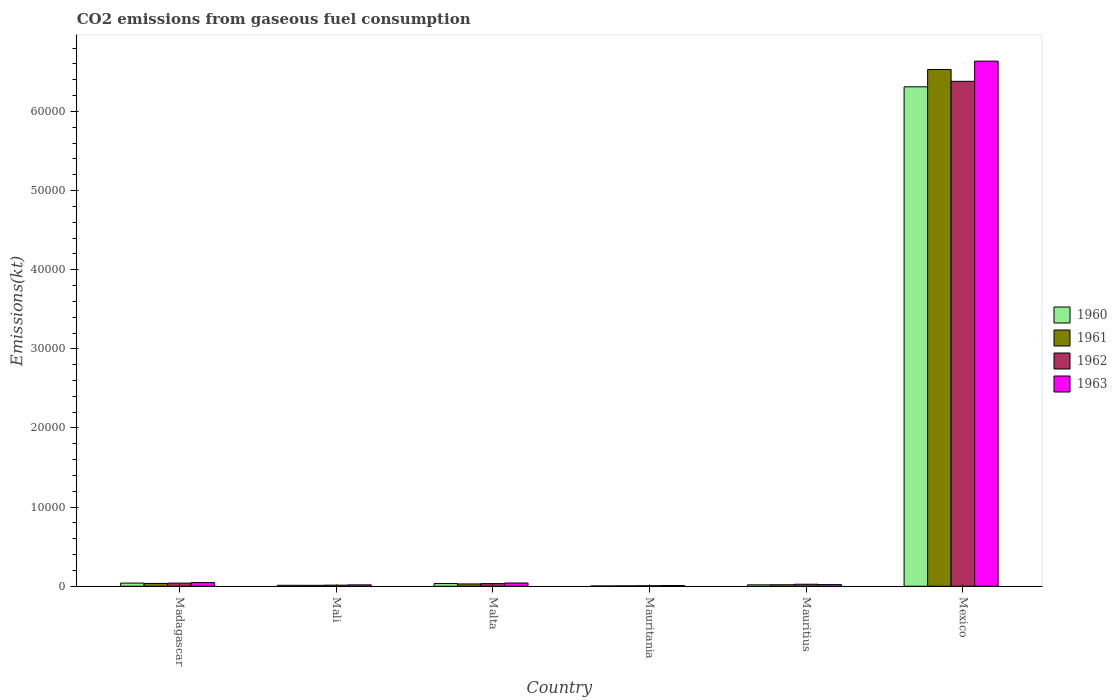Are the number of bars on each tick of the X-axis equal?
Offer a very short reply. Yes. What is the label of the 5th group of bars from the left?
Give a very brief answer. Mauritius. What is the amount of CO2 emitted in 1963 in Mauritius?
Your response must be concise. 209.02. Across all countries, what is the maximum amount of CO2 emitted in 1963?
Provide a succinct answer. 6.64e+04. Across all countries, what is the minimum amount of CO2 emitted in 1961?
Make the answer very short. 47.67. In which country was the amount of CO2 emitted in 1963 maximum?
Keep it short and to the point. Mexico. In which country was the amount of CO2 emitted in 1963 minimum?
Ensure brevity in your answer.  Mauritania. What is the total amount of CO2 emitted in 1961 in the graph?
Your answer should be compact. 6.63e+04. What is the difference between the amount of CO2 emitted in 1961 in Mauritius and that in Mexico?
Your response must be concise. -6.51e+04. What is the difference between the amount of CO2 emitted in 1961 in Malta and the amount of CO2 emitted in 1963 in Mali?
Make the answer very short. 117.34. What is the average amount of CO2 emitted in 1960 per country?
Offer a terse response. 1.07e+04. What is the difference between the amount of CO2 emitted of/in 1962 and amount of CO2 emitted of/in 1963 in Mali?
Your response must be concise. -36.67. In how many countries, is the amount of CO2 emitted in 1963 greater than 4000 kt?
Provide a short and direct response. 1. What is the ratio of the amount of CO2 emitted in 1963 in Mauritius to that in Mexico?
Give a very brief answer. 0. Is the amount of CO2 emitted in 1961 in Madagascar less than that in Mauritius?
Your answer should be very brief. No. What is the difference between the highest and the second highest amount of CO2 emitted in 1962?
Give a very brief answer. 6.35e+04. What is the difference between the highest and the lowest amount of CO2 emitted in 1963?
Your answer should be compact. 6.63e+04. In how many countries, is the amount of CO2 emitted in 1962 greater than the average amount of CO2 emitted in 1962 taken over all countries?
Provide a succinct answer. 1. Is it the case that in every country, the sum of the amount of CO2 emitted in 1963 and amount of CO2 emitted in 1960 is greater than the sum of amount of CO2 emitted in 1961 and amount of CO2 emitted in 1962?
Make the answer very short. No. What does the 1st bar from the left in Mali represents?
Make the answer very short. 1960. Is it the case that in every country, the sum of the amount of CO2 emitted in 1962 and amount of CO2 emitted in 1960 is greater than the amount of CO2 emitted in 1961?
Your answer should be compact. Yes. How many bars are there?
Provide a short and direct response. 24. Are all the bars in the graph horizontal?
Keep it short and to the point. No. How many countries are there in the graph?
Make the answer very short. 6. What is the difference between two consecutive major ticks on the Y-axis?
Your answer should be compact. 10000. Are the values on the major ticks of Y-axis written in scientific E-notation?
Keep it short and to the point. No. How many legend labels are there?
Make the answer very short. 4. What is the title of the graph?
Make the answer very short. CO2 emissions from gaseous fuel consumption. Does "1982" appear as one of the legend labels in the graph?
Your response must be concise. No. What is the label or title of the X-axis?
Make the answer very short. Country. What is the label or title of the Y-axis?
Keep it short and to the point. Emissions(kt). What is the Emissions(kt) in 1960 in Madagascar?
Offer a terse response. 399.7. What is the Emissions(kt) in 1961 in Madagascar?
Offer a terse response. 355.7. What is the Emissions(kt) of 1962 in Madagascar?
Keep it short and to the point. 396.04. What is the Emissions(kt) of 1963 in Madagascar?
Offer a very short reply. 462.04. What is the Emissions(kt) in 1960 in Mali?
Your response must be concise. 121.01. What is the Emissions(kt) of 1961 in Mali?
Your answer should be compact. 117.34. What is the Emissions(kt) of 1962 in Mali?
Keep it short and to the point. 139.35. What is the Emissions(kt) of 1963 in Mali?
Offer a terse response. 176.02. What is the Emissions(kt) in 1960 in Malta?
Offer a terse response. 341.03. What is the Emissions(kt) of 1961 in Malta?
Provide a short and direct response. 293.36. What is the Emissions(kt) in 1962 in Malta?
Provide a succinct answer. 330.03. What is the Emissions(kt) of 1963 in Malta?
Your answer should be very brief. 410.7. What is the Emissions(kt) in 1960 in Mauritania?
Your response must be concise. 36.67. What is the Emissions(kt) of 1961 in Mauritania?
Provide a succinct answer. 47.67. What is the Emissions(kt) of 1962 in Mauritania?
Ensure brevity in your answer.  62.34. What is the Emissions(kt) in 1963 in Mauritania?
Your answer should be compact. 88.01. What is the Emissions(kt) of 1960 in Mauritius?
Give a very brief answer. 179.68. What is the Emissions(kt) of 1961 in Mauritius?
Ensure brevity in your answer.  187.02. What is the Emissions(kt) of 1962 in Mauritius?
Offer a very short reply. 253.02. What is the Emissions(kt) of 1963 in Mauritius?
Keep it short and to the point. 209.02. What is the Emissions(kt) of 1960 in Mexico?
Your answer should be compact. 6.31e+04. What is the Emissions(kt) in 1961 in Mexico?
Give a very brief answer. 6.53e+04. What is the Emissions(kt) in 1962 in Mexico?
Your response must be concise. 6.38e+04. What is the Emissions(kt) of 1963 in Mexico?
Give a very brief answer. 6.64e+04. Across all countries, what is the maximum Emissions(kt) of 1960?
Offer a terse response. 6.31e+04. Across all countries, what is the maximum Emissions(kt) in 1961?
Give a very brief answer. 6.53e+04. Across all countries, what is the maximum Emissions(kt) of 1962?
Your response must be concise. 6.38e+04. Across all countries, what is the maximum Emissions(kt) in 1963?
Offer a terse response. 6.64e+04. Across all countries, what is the minimum Emissions(kt) of 1960?
Your answer should be compact. 36.67. Across all countries, what is the minimum Emissions(kt) of 1961?
Offer a terse response. 47.67. Across all countries, what is the minimum Emissions(kt) of 1962?
Offer a terse response. 62.34. Across all countries, what is the minimum Emissions(kt) in 1963?
Keep it short and to the point. 88.01. What is the total Emissions(kt) of 1960 in the graph?
Offer a very short reply. 6.42e+04. What is the total Emissions(kt) of 1961 in the graph?
Offer a very short reply. 6.63e+04. What is the total Emissions(kt) of 1962 in the graph?
Make the answer very short. 6.50e+04. What is the total Emissions(kt) in 1963 in the graph?
Your response must be concise. 6.77e+04. What is the difference between the Emissions(kt) of 1960 in Madagascar and that in Mali?
Your answer should be very brief. 278.69. What is the difference between the Emissions(kt) of 1961 in Madagascar and that in Mali?
Provide a short and direct response. 238.35. What is the difference between the Emissions(kt) in 1962 in Madagascar and that in Mali?
Offer a very short reply. 256.69. What is the difference between the Emissions(kt) of 1963 in Madagascar and that in Mali?
Make the answer very short. 286.03. What is the difference between the Emissions(kt) in 1960 in Madagascar and that in Malta?
Your response must be concise. 58.67. What is the difference between the Emissions(kt) of 1961 in Madagascar and that in Malta?
Provide a short and direct response. 62.34. What is the difference between the Emissions(kt) in 1962 in Madagascar and that in Malta?
Offer a terse response. 66.01. What is the difference between the Emissions(kt) of 1963 in Madagascar and that in Malta?
Provide a short and direct response. 51.34. What is the difference between the Emissions(kt) of 1960 in Madagascar and that in Mauritania?
Offer a terse response. 363.03. What is the difference between the Emissions(kt) in 1961 in Madagascar and that in Mauritania?
Provide a short and direct response. 308.03. What is the difference between the Emissions(kt) of 1962 in Madagascar and that in Mauritania?
Ensure brevity in your answer.  333.7. What is the difference between the Emissions(kt) in 1963 in Madagascar and that in Mauritania?
Ensure brevity in your answer.  374.03. What is the difference between the Emissions(kt) of 1960 in Madagascar and that in Mauritius?
Provide a short and direct response. 220.02. What is the difference between the Emissions(kt) in 1961 in Madagascar and that in Mauritius?
Your response must be concise. 168.68. What is the difference between the Emissions(kt) of 1962 in Madagascar and that in Mauritius?
Offer a very short reply. 143.01. What is the difference between the Emissions(kt) of 1963 in Madagascar and that in Mauritius?
Give a very brief answer. 253.02. What is the difference between the Emissions(kt) of 1960 in Madagascar and that in Mexico?
Your answer should be compact. -6.27e+04. What is the difference between the Emissions(kt) of 1961 in Madagascar and that in Mexico?
Offer a very short reply. -6.49e+04. What is the difference between the Emissions(kt) of 1962 in Madagascar and that in Mexico?
Offer a terse response. -6.34e+04. What is the difference between the Emissions(kt) of 1963 in Madagascar and that in Mexico?
Give a very brief answer. -6.59e+04. What is the difference between the Emissions(kt) in 1960 in Mali and that in Malta?
Provide a succinct answer. -220.02. What is the difference between the Emissions(kt) in 1961 in Mali and that in Malta?
Offer a terse response. -176.02. What is the difference between the Emissions(kt) in 1962 in Mali and that in Malta?
Your response must be concise. -190.68. What is the difference between the Emissions(kt) in 1963 in Mali and that in Malta?
Provide a short and direct response. -234.69. What is the difference between the Emissions(kt) in 1960 in Mali and that in Mauritania?
Provide a short and direct response. 84.34. What is the difference between the Emissions(kt) of 1961 in Mali and that in Mauritania?
Ensure brevity in your answer.  69.67. What is the difference between the Emissions(kt) of 1962 in Mali and that in Mauritania?
Your answer should be compact. 77.01. What is the difference between the Emissions(kt) in 1963 in Mali and that in Mauritania?
Provide a succinct answer. 88.01. What is the difference between the Emissions(kt) in 1960 in Mali and that in Mauritius?
Provide a succinct answer. -58.67. What is the difference between the Emissions(kt) in 1961 in Mali and that in Mauritius?
Make the answer very short. -69.67. What is the difference between the Emissions(kt) of 1962 in Mali and that in Mauritius?
Give a very brief answer. -113.68. What is the difference between the Emissions(kt) of 1963 in Mali and that in Mauritius?
Your response must be concise. -33. What is the difference between the Emissions(kt) in 1960 in Mali and that in Mexico?
Offer a very short reply. -6.30e+04. What is the difference between the Emissions(kt) in 1961 in Mali and that in Mexico?
Ensure brevity in your answer.  -6.52e+04. What is the difference between the Emissions(kt) of 1962 in Mali and that in Mexico?
Your response must be concise. -6.37e+04. What is the difference between the Emissions(kt) of 1963 in Mali and that in Mexico?
Your answer should be very brief. -6.62e+04. What is the difference between the Emissions(kt) in 1960 in Malta and that in Mauritania?
Your response must be concise. 304.36. What is the difference between the Emissions(kt) of 1961 in Malta and that in Mauritania?
Ensure brevity in your answer.  245.69. What is the difference between the Emissions(kt) in 1962 in Malta and that in Mauritania?
Offer a very short reply. 267.69. What is the difference between the Emissions(kt) in 1963 in Malta and that in Mauritania?
Make the answer very short. 322.7. What is the difference between the Emissions(kt) in 1960 in Malta and that in Mauritius?
Make the answer very short. 161.35. What is the difference between the Emissions(kt) in 1961 in Malta and that in Mauritius?
Ensure brevity in your answer.  106.34. What is the difference between the Emissions(kt) in 1962 in Malta and that in Mauritius?
Give a very brief answer. 77.01. What is the difference between the Emissions(kt) in 1963 in Malta and that in Mauritius?
Ensure brevity in your answer.  201.69. What is the difference between the Emissions(kt) of 1960 in Malta and that in Mexico?
Offer a very short reply. -6.28e+04. What is the difference between the Emissions(kt) of 1961 in Malta and that in Mexico?
Keep it short and to the point. -6.50e+04. What is the difference between the Emissions(kt) of 1962 in Malta and that in Mexico?
Your answer should be compact. -6.35e+04. What is the difference between the Emissions(kt) in 1963 in Malta and that in Mexico?
Your answer should be very brief. -6.60e+04. What is the difference between the Emissions(kt) in 1960 in Mauritania and that in Mauritius?
Your response must be concise. -143.01. What is the difference between the Emissions(kt) in 1961 in Mauritania and that in Mauritius?
Make the answer very short. -139.35. What is the difference between the Emissions(kt) of 1962 in Mauritania and that in Mauritius?
Keep it short and to the point. -190.68. What is the difference between the Emissions(kt) of 1963 in Mauritania and that in Mauritius?
Your answer should be very brief. -121.01. What is the difference between the Emissions(kt) in 1960 in Mauritania and that in Mexico?
Your answer should be compact. -6.31e+04. What is the difference between the Emissions(kt) of 1961 in Mauritania and that in Mexico?
Ensure brevity in your answer.  -6.53e+04. What is the difference between the Emissions(kt) in 1962 in Mauritania and that in Mexico?
Your answer should be very brief. -6.37e+04. What is the difference between the Emissions(kt) in 1963 in Mauritania and that in Mexico?
Keep it short and to the point. -6.63e+04. What is the difference between the Emissions(kt) of 1960 in Mauritius and that in Mexico?
Keep it short and to the point. -6.29e+04. What is the difference between the Emissions(kt) in 1961 in Mauritius and that in Mexico?
Your answer should be compact. -6.51e+04. What is the difference between the Emissions(kt) in 1962 in Mauritius and that in Mexico?
Your answer should be very brief. -6.36e+04. What is the difference between the Emissions(kt) in 1963 in Mauritius and that in Mexico?
Your answer should be very brief. -6.62e+04. What is the difference between the Emissions(kt) in 1960 in Madagascar and the Emissions(kt) in 1961 in Mali?
Your response must be concise. 282.36. What is the difference between the Emissions(kt) in 1960 in Madagascar and the Emissions(kt) in 1962 in Mali?
Your answer should be compact. 260.36. What is the difference between the Emissions(kt) in 1960 in Madagascar and the Emissions(kt) in 1963 in Mali?
Your answer should be very brief. 223.69. What is the difference between the Emissions(kt) of 1961 in Madagascar and the Emissions(kt) of 1962 in Mali?
Provide a succinct answer. 216.35. What is the difference between the Emissions(kt) of 1961 in Madagascar and the Emissions(kt) of 1963 in Mali?
Give a very brief answer. 179.68. What is the difference between the Emissions(kt) of 1962 in Madagascar and the Emissions(kt) of 1963 in Mali?
Offer a terse response. 220.02. What is the difference between the Emissions(kt) of 1960 in Madagascar and the Emissions(kt) of 1961 in Malta?
Make the answer very short. 106.34. What is the difference between the Emissions(kt) in 1960 in Madagascar and the Emissions(kt) in 1962 in Malta?
Offer a very short reply. 69.67. What is the difference between the Emissions(kt) in 1960 in Madagascar and the Emissions(kt) in 1963 in Malta?
Keep it short and to the point. -11. What is the difference between the Emissions(kt) in 1961 in Madagascar and the Emissions(kt) in 1962 in Malta?
Offer a terse response. 25.67. What is the difference between the Emissions(kt) of 1961 in Madagascar and the Emissions(kt) of 1963 in Malta?
Your answer should be very brief. -55.01. What is the difference between the Emissions(kt) in 1962 in Madagascar and the Emissions(kt) in 1963 in Malta?
Ensure brevity in your answer.  -14.67. What is the difference between the Emissions(kt) of 1960 in Madagascar and the Emissions(kt) of 1961 in Mauritania?
Your answer should be very brief. 352.03. What is the difference between the Emissions(kt) in 1960 in Madagascar and the Emissions(kt) in 1962 in Mauritania?
Offer a terse response. 337.36. What is the difference between the Emissions(kt) of 1960 in Madagascar and the Emissions(kt) of 1963 in Mauritania?
Offer a terse response. 311.69. What is the difference between the Emissions(kt) of 1961 in Madagascar and the Emissions(kt) of 1962 in Mauritania?
Your response must be concise. 293.36. What is the difference between the Emissions(kt) in 1961 in Madagascar and the Emissions(kt) in 1963 in Mauritania?
Provide a succinct answer. 267.69. What is the difference between the Emissions(kt) of 1962 in Madagascar and the Emissions(kt) of 1963 in Mauritania?
Provide a succinct answer. 308.03. What is the difference between the Emissions(kt) of 1960 in Madagascar and the Emissions(kt) of 1961 in Mauritius?
Make the answer very short. 212.69. What is the difference between the Emissions(kt) of 1960 in Madagascar and the Emissions(kt) of 1962 in Mauritius?
Keep it short and to the point. 146.68. What is the difference between the Emissions(kt) of 1960 in Madagascar and the Emissions(kt) of 1963 in Mauritius?
Your response must be concise. 190.68. What is the difference between the Emissions(kt) of 1961 in Madagascar and the Emissions(kt) of 1962 in Mauritius?
Offer a very short reply. 102.68. What is the difference between the Emissions(kt) in 1961 in Madagascar and the Emissions(kt) in 1963 in Mauritius?
Your response must be concise. 146.68. What is the difference between the Emissions(kt) of 1962 in Madagascar and the Emissions(kt) of 1963 in Mauritius?
Provide a succinct answer. 187.02. What is the difference between the Emissions(kt) in 1960 in Madagascar and the Emissions(kt) in 1961 in Mexico?
Offer a terse response. -6.49e+04. What is the difference between the Emissions(kt) of 1960 in Madagascar and the Emissions(kt) of 1962 in Mexico?
Keep it short and to the point. -6.34e+04. What is the difference between the Emissions(kt) of 1960 in Madagascar and the Emissions(kt) of 1963 in Mexico?
Keep it short and to the point. -6.60e+04. What is the difference between the Emissions(kt) of 1961 in Madagascar and the Emissions(kt) of 1962 in Mexico?
Provide a succinct answer. -6.35e+04. What is the difference between the Emissions(kt) in 1961 in Madagascar and the Emissions(kt) in 1963 in Mexico?
Your answer should be compact. -6.60e+04. What is the difference between the Emissions(kt) of 1962 in Madagascar and the Emissions(kt) of 1963 in Mexico?
Your answer should be very brief. -6.60e+04. What is the difference between the Emissions(kt) of 1960 in Mali and the Emissions(kt) of 1961 in Malta?
Provide a succinct answer. -172.35. What is the difference between the Emissions(kt) in 1960 in Mali and the Emissions(kt) in 1962 in Malta?
Provide a succinct answer. -209.02. What is the difference between the Emissions(kt) of 1960 in Mali and the Emissions(kt) of 1963 in Malta?
Offer a terse response. -289.69. What is the difference between the Emissions(kt) of 1961 in Mali and the Emissions(kt) of 1962 in Malta?
Your answer should be compact. -212.69. What is the difference between the Emissions(kt) in 1961 in Mali and the Emissions(kt) in 1963 in Malta?
Keep it short and to the point. -293.36. What is the difference between the Emissions(kt) of 1962 in Mali and the Emissions(kt) of 1963 in Malta?
Provide a short and direct response. -271.36. What is the difference between the Emissions(kt) in 1960 in Mali and the Emissions(kt) in 1961 in Mauritania?
Ensure brevity in your answer.  73.34. What is the difference between the Emissions(kt) of 1960 in Mali and the Emissions(kt) of 1962 in Mauritania?
Offer a very short reply. 58.67. What is the difference between the Emissions(kt) of 1960 in Mali and the Emissions(kt) of 1963 in Mauritania?
Offer a very short reply. 33. What is the difference between the Emissions(kt) of 1961 in Mali and the Emissions(kt) of 1962 in Mauritania?
Your response must be concise. 55.01. What is the difference between the Emissions(kt) in 1961 in Mali and the Emissions(kt) in 1963 in Mauritania?
Provide a succinct answer. 29.34. What is the difference between the Emissions(kt) of 1962 in Mali and the Emissions(kt) of 1963 in Mauritania?
Make the answer very short. 51.34. What is the difference between the Emissions(kt) of 1960 in Mali and the Emissions(kt) of 1961 in Mauritius?
Provide a succinct answer. -66.01. What is the difference between the Emissions(kt) of 1960 in Mali and the Emissions(kt) of 1962 in Mauritius?
Ensure brevity in your answer.  -132.01. What is the difference between the Emissions(kt) of 1960 in Mali and the Emissions(kt) of 1963 in Mauritius?
Provide a succinct answer. -88.01. What is the difference between the Emissions(kt) of 1961 in Mali and the Emissions(kt) of 1962 in Mauritius?
Make the answer very short. -135.68. What is the difference between the Emissions(kt) in 1961 in Mali and the Emissions(kt) in 1963 in Mauritius?
Ensure brevity in your answer.  -91.67. What is the difference between the Emissions(kt) in 1962 in Mali and the Emissions(kt) in 1963 in Mauritius?
Keep it short and to the point. -69.67. What is the difference between the Emissions(kt) of 1960 in Mali and the Emissions(kt) of 1961 in Mexico?
Your response must be concise. -6.52e+04. What is the difference between the Emissions(kt) in 1960 in Mali and the Emissions(kt) in 1962 in Mexico?
Provide a short and direct response. -6.37e+04. What is the difference between the Emissions(kt) in 1960 in Mali and the Emissions(kt) in 1963 in Mexico?
Offer a terse response. -6.62e+04. What is the difference between the Emissions(kt) of 1961 in Mali and the Emissions(kt) of 1962 in Mexico?
Provide a short and direct response. -6.37e+04. What is the difference between the Emissions(kt) in 1961 in Mali and the Emissions(kt) in 1963 in Mexico?
Ensure brevity in your answer.  -6.62e+04. What is the difference between the Emissions(kt) of 1962 in Mali and the Emissions(kt) of 1963 in Mexico?
Provide a short and direct response. -6.62e+04. What is the difference between the Emissions(kt) of 1960 in Malta and the Emissions(kt) of 1961 in Mauritania?
Offer a terse response. 293.36. What is the difference between the Emissions(kt) of 1960 in Malta and the Emissions(kt) of 1962 in Mauritania?
Make the answer very short. 278.69. What is the difference between the Emissions(kt) in 1960 in Malta and the Emissions(kt) in 1963 in Mauritania?
Your response must be concise. 253.02. What is the difference between the Emissions(kt) of 1961 in Malta and the Emissions(kt) of 1962 in Mauritania?
Ensure brevity in your answer.  231.02. What is the difference between the Emissions(kt) of 1961 in Malta and the Emissions(kt) of 1963 in Mauritania?
Give a very brief answer. 205.35. What is the difference between the Emissions(kt) of 1962 in Malta and the Emissions(kt) of 1963 in Mauritania?
Give a very brief answer. 242.02. What is the difference between the Emissions(kt) of 1960 in Malta and the Emissions(kt) of 1961 in Mauritius?
Make the answer very short. 154.01. What is the difference between the Emissions(kt) in 1960 in Malta and the Emissions(kt) in 1962 in Mauritius?
Your answer should be compact. 88.01. What is the difference between the Emissions(kt) in 1960 in Malta and the Emissions(kt) in 1963 in Mauritius?
Keep it short and to the point. 132.01. What is the difference between the Emissions(kt) of 1961 in Malta and the Emissions(kt) of 1962 in Mauritius?
Your answer should be very brief. 40.34. What is the difference between the Emissions(kt) of 1961 in Malta and the Emissions(kt) of 1963 in Mauritius?
Your response must be concise. 84.34. What is the difference between the Emissions(kt) in 1962 in Malta and the Emissions(kt) in 1963 in Mauritius?
Your response must be concise. 121.01. What is the difference between the Emissions(kt) of 1960 in Malta and the Emissions(kt) of 1961 in Mexico?
Provide a short and direct response. -6.50e+04. What is the difference between the Emissions(kt) in 1960 in Malta and the Emissions(kt) in 1962 in Mexico?
Offer a terse response. -6.35e+04. What is the difference between the Emissions(kt) of 1960 in Malta and the Emissions(kt) of 1963 in Mexico?
Ensure brevity in your answer.  -6.60e+04. What is the difference between the Emissions(kt) in 1961 in Malta and the Emissions(kt) in 1962 in Mexico?
Provide a succinct answer. -6.35e+04. What is the difference between the Emissions(kt) of 1961 in Malta and the Emissions(kt) of 1963 in Mexico?
Your answer should be very brief. -6.61e+04. What is the difference between the Emissions(kt) of 1962 in Malta and the Emissions(kt) of 1963 in Mexico?
Offer a terse response. -6.60e+04. What is the difference between the Emissions(kt) in 1960 in Mauritania and the Emissions(kt) in 1961 in Mauritius?
Offer a terse response. -150.35. What is the difference between the Emissions(kt) in 1960 in Mauritania and the Emissions(kt) in 1962 in Mauritius?
Provide a short and direct response. -216.35. What is the difference between the Emissions(kt) of 1960 in Mauritania and the Emissions(kt) of 1963 in Mauritius?
Ensure brevity in your answer.  -172.35. What is the difference between the Emissions(kt) of 1961 in Mauritania and the Emissions(kt) of 1962 in Mauritius?
Your answer should be compact. -205.35. What is the difference between the Emissions(kt) in 1961 in Mauritania and the Emissions(kt) in 1963 in Mauritius?
Keep it short and to the point. -161.35. What is the difference between the Emissions(kt) in 1962 in Mauritania and the Emissions(kt) in 1963 in Mauritius?
Offer a very short reply. -146.68. What is the difference between the Emissions(kt) in 1960 in Mauritania and the Emissions(kt) in 1961 in Mexico?
Your answer should be very brief. -6.53e+04. What is the difference between the Emissions(kt) of 1960 in Mauritania and the Emissions(kt) of 1962 in Mexico?
Provide a succinct answer. -6.38e+04. What is the difference between the Emissions(kt) in 1960 in Mauritania and the Emissions(kt) in 1963 in Mexico?
Keep it short and to the point. -6.63e+04. What is the difference between the Emissions(kt) of 1961 in Mauritania and the Emissions(kt) of 1962 in Mexico?
Provide a short and direct response. -6.38e+04. What is the difference between the Emissions(kt) of 1961 in Mauritania and the Emissions(kt) of 1963 in Mexico?
Give a very brief answer. -6.63e+04. What is the difference between the Emissions(kt) of 1962 in Mauritania and the Emissions(kt) of 1963 in Mexico?
Give a very brief answer. -6.63e+04. What is the difference between the Emissions(kt) in 1960 in Mauritius and the Emissions(kt) in 1961 in Mexico?
Provide a succinct answer. -6.51e+04. What is the difference between the Emissions(kt) of 1960 in Mauritius and the Emissions(kt) of 1962 in Mexico?
Offer a very short reply. -6.36e+04. What is the difference between the Emissions(kt) in 1960 in Mauritius and the Emissions(kt) in 1963 in Mexico?
Offer a terse response. -6.62e+04. What is the difference between the Emissions(kt) of 1961 in Mauritius and the Emissions(kt) of 1962 in Mexico?
Give a very brief answer. -6.36e+04. What is the difference between the Emissions(kt) of 1961 in Mauritius and the Emissions(kt) of 1963 in Mexico?
Make the answer very short. -6.62e+04. What is the difference between the Emissions(kt) in 1962 in Mauritius and the Emissions(kt) in 1963 in Mexico?
Ensure brevity in your answer.  -6.61e+04. What is the average Emissions(kt) in 1960 per country?
Offer a very short reply. 1.07e+04. What is the average Emissions(kt) in 1961 per country?
Your answer should be compact. 1.11e+04. What is the average Emissions(kt) of 1962 per country?
Ensure brevity in your answer.  1.08e+04. What is the average Emissions(kt) of 1963 per country?
Provide a succinct answer. 1.13e+04. What is the difference between the Emissions(kt) of 1960 and Emissions(kt) of 1961 in Madagascar?
Make the answer very short. 44. What is the difference between the Emissions(kt) in 1960 and Emissions(kt) in 1962 in Madagascar?
Your answer should be very brief. 3.67. What is the difference between the Emissions(kt) in 1960 and Emissions(kt) in 1963 in Madagascar?
Ensure brevity in your answer.  -62.34. What is the difference between the Emissions(kt) in 1961 and Emissions(kt) in 1962 in Madagascar?
Ensure brevity in your answer.  -40.34. What is the difference between the Emissions(kt) of 1961 and Emissions(kt) of 1963 in Madagascar?
Give a very brief answer. -106.34. What is the difference between the Emissions(kt) in 1962 and Emissions(kt) in 1963 in Madagascar?
Your response must be concise. -66.01. What is the difference between the Emissions(kt) in 1960 and Emissions(kt) in 1961 in Mali?
Ensure brevity in your answer.  3.67. What is the difference between the Emissions(kt) of 1960 and Emissions(kt) of 1962 in Mali?
Keep it short and to the point. -18.34. What is the difference between the Emissions(kt) of 1960 and Emissions(kt) of 1963 in Mali?
Keep it short and to the point. -55.01. What is the difference between the Emissions(kt) of 1961 and Emissions(kt) of 1962 in Mali?
Give a very brief answer. -22. What is the difference between the Emissions(kt) of 1961 and Emissions(kt) of 1963 in Mali?
Ensure brevity in your answer.  -58.67. What is the difference between the Emissions(kt) of 1962 and Emissions(kt) of 1963 in Mali?
Ensure brevity in your answer.  -36.67. What is the difference between the Emissions(kt) in 1960 and Emissions(kt) in 1961 in Malta?
Your answer should be compact. 47.67. What is the difference between the Emissions(kt) of 1960 and Emissions(kt) of 1962 in Malta?
Ensure brevity in your answer.  11. What is the difference between the Emissions(kt) in 1960 and Emissions(kt) in 1963 in Malta?
Your response must be concise. -69.67. What is the difference between the Emissions(kt) in 1961 and Emissions(kt) in 1962 in Malta?
Provide a succinct answer. -36.67. What is the difference between the Emissions(kt) of 1961 and Emissions(kt) of 1963 in Malta?
Ensure brevity in your answer.  -117.34. What is the difference between the Emissions(kt) of 1962 and Emissions(kt) of 1963 in Malta?
Offer a terse response. -80.67. What is the difference between the Emissions(kt) of 1960 and Emissions(kt) of 1961 in Mauritania?
Your answer should be compact. -11. What is the difference between the Emissions(kt) in 1960 and Emissions(kt) in 1962 in Mauritania?
Provide a short and direct response. -25.67. What is the difference between the Emissions(kt) in 1960 and Emissions(kt) in 1963 in Mauritania?
Your response must be concise. -51.34. What is the difference between the Emissions(kt) of 1961 and Emissions(kt) of 1962 in Mauritania?
Your response must be concise. -14.67. What is the difference between the Emissions(kt) in 1961 and Emissions(kt) in 1963 in Mauritania?
Provide a succinct answer. -40.34. What is the difference between the Emissions(kt) of 1962 and Emissions(kt) of 1963 in Mauritania?
Your answer should be very brief. -25.67. What is the difference between the Emissions(kt) of 1960 and Emissions(kt) of 1961 in Mauritius?
Ensure brevity in your answer.  -7.33. What is the difference between the Emissions(kt) of 1960 and Emissions(kt) of 1962 in Mauritius?
Your response must be concise. -73.34. What is the difference between the Emissions(kt) in 1960 and Emissions(kt) in 1963 in Mauritius?
Keep it short and to the point. -29.34. What is the difference between the Emissions(kt) of 1961 and Emissions(kt) of 1962 in Mauritius?
Offer a terse response. -66.01. What is the difference between the Emissions(kt) in 1961 and Emissions(kt) in 1963 in Mauritius?
Offer a very short reply. -22. What is the difference between the Emissions(kt) in 1962 and Emissions(kt) in 1963 in Mauritius?
Keep it short and to the point. 44. What is the difference between the Emissions(kt) in 1960 and Emissions(kt) in 1961 in Mexico?
Your answer should be compact. -2189.2. What is the difference between the Emissions(kt) of 1960 and Emissions(kt) of 1962 in Mexico?
Make the answer very short. -693.06. What is the difference between the Emissions(kt) in 1960 and Emissions(kt) in 1963 in Mexico?
Your answer should be very brief. -3245.3. What is the difference between the Emissions(kt) in 1961 and Emissions(kt) in 1962 in Mexico?
Ensure brevity in your answer.  1496.14. What is the difference between the Emissions(kt) of 1961 and Emissions(kt) of 1963 in Mexico?
Make the answer very short. -1056.1. What is the difference between the Emissions(kt) of 1962 and Emissions(kt) of 1963 in Mexico?
Offer a very short reply. -2552.23. What is the ratio of the Emissions(kt) in 1960 in Madagascar to that in Mali?
Provide a succinct answer. 3.3. What is the ratio of the Emissions(kt) of 1961 in Madagascar to that in Mali?
Your answer should be very brief. 3.03. What is the ratio of the Emissions(kt) in 1962 in Madagascar to that in Mali?
Provide a short and direct response. 2.84. What is the ratio of the Emissions(kt) of 1963 in Madagascar to that in Mali?
Provide a short and direct response. 2.62. What is the ratio of the Emissions(kt) of 1960 in Madagascar to that in Malta?
Your answer should be very brief. 1.17. What is the ratio of the Emissions(kt) in 1961 in Madagascar to that in Malta?
Provide a succinct answer. 1.21. What is the ratio of the Emissions(kt) of 1962 in Madagascar to that in Malta?
Your answer should be compact. 1.2. What is the ratio of the Emissions(kt) of 1960 in Madagascar to that in Mauritania?
Make the answer very short. 10.9. What is the ratio of the Emissions(kt) in 1961 in Madagascar to that in Mauritania?
Your answer should be very brief. 7.46. What is the ratio of the Emissions(kt) of 1962 in Madagascar to that in Mauritania?
Offer a terse response. 6.35. What is the ratio of the Emissions(kt) in 1963 in Madagascar to that in Mauritania?
Provide a succinct answer. 5.25. What is the ratio of the Emissions(kt) of 1960 in Madagascar to that in Mauritius?
Provide a succinct answer. 2.22. What is the ratio of the Emissions(kt) of 1961 in Madagascar to that in Mauritius?
Give a very brief answer. 1.9. What is the ratio of the Emissions(kt) in 1962 in Madagascar to that in Mauritius?
Keep it short and to the point. 1.57. What is the ratio of the Emissions(kt) of 1963 in Madagascar to that in Mauritius?
Provide a short and direct response. 2.21. What is the ratio of the Emissions(kt) in 1960 in Madagascar to that in Mexico?
Provide a short and direct response. 0.01. What is the ratio of the Emissions(kt) in 1961 in Madagascar to that in Mexico?
Your answer should be very brief. 0.01. What is the ratio of the Emissions(kt) in 1962 in Madagascar to that in Mexico?
Offer a terse response. 0.01. What is the ratio of the Emissions(kt) in 1963 in Madagascar to that in Mexico?
Your answer should be compact. 0.01. What is the ratio of the Emissions(kt) of 1960 in Mali to that in Malta?
Provide a succinct answer. 0.35. What is the ratio of the Emissions(kt) in 1961 in Mali to that in Malta?
Offer a very short reply. 0.4. What is the ratio of the Emissions(kt) in 1962 in Mali to that in Malta?
Your answer should be very brief. 0.42. What is the ratio of the Emissions(kt) in 1963 in Mali to that in Malta?
Offer a very short reply. 0.43. What is the ratio of the Emissions(kt) of 1961 in Mali to that in Mauritania?
Keep it short and to the point. 2.46. What is the ratio of the Emissions(kt) of 1962 in Mali to that in Mauritania?
Ensure brevity in your answer.  2.24. What is the ratio of the Emissions(kt) in 1963 in Mali to that in Mauritania?
Offer a very short reply. 2. What is the ratio of the Emissions(kt) of 1960 in Mali to that in Mauritius?
Offer a very short reply. 0.67. What is the ratio of the Emissions(kt) of 1961 in Mali to that in Mauritius?
Keep it short and to the point. 0.63. What is the ratio of the Emissions(kt) of 1962 in Mali to that in Mauritius?
Provide a short and direct response. 0.55. What is the ratio of the Emissions(kt) in 1963 in Mali to that in Mauritius?
Keep it short and to the point. 0.84. What is the ratio of the Emissions(kt) in 1960 in Mali to that in Mexico?
Make the answer very short. 0. What is the ratio of the Emissions(kt) of 1961 in Mali to that in Mexico?
Offer a terse response. 0. What is the ratio of the Emissions(kt) of 1962 in Mali to that in Mexico?
Offer a very short reply. 0. What is the ratio of the Emissions(kt) of 1963 in Mali to that in Mexico?
Make the answer very short. 0. What is the ratio of the Emissions(kt) of 1961 in Malta to that in Mauritania?
Offer a very short reply. 6.15. What is the ratio of the Emissions(kt) of 1962 in Malta to that in Mauritania?
Your response must be concise. 5.29. What is the ratio of the Emissions(kt) in 1963 in Malta to that in Mauritania?
Provide a short and direct response. 4.67. What is the ratio of the Emissions(kt) in 1960 in Malta to that in Mauritius?
Provide a short and direct response. 1.9. What is the ratio of the Emissions(kt) of 1961 in Malta to that in Mauritius?
Offer a terse response. 1.57. What is the ratio of the Emissions(kt) in 1962 in Malta to that in Mauritius?
Keep it short and to the point. 1.3. What is the ratio of the Emissions(kt) in 1963 in Malta to that in Mauritius?
Offer a terse response. 1.96. What is the ratio of the Emissions(kt) in 1960 in Malta to that in Mexico?
Ensure brevity in your answer.  0.01. What is the ratio of the Emissions(kt) of 1961 in Malta to that in Mexico?
Provide a succinct answer. 0. What is the ratio of the Emissions(kt) of 1962 in Malta to that in Mexico?
Keep it short and to the point. 0.01. What is the ratio of the Emissions(kt) of 1963 in Malta to that in Mexico?
Offer a very short reply. 0.01. What is the ratio of the Emissions(kt) of 1960 in Mauritania to that in Mauritius?
Offer a very short reply. 0.2. What is the ratio of the Emissions(kt) in 1961 in Mauritania to that in Mauritius?
Give a very brief answer. 0.25. What is the ratio of the Emissions(kt) of 1962 in Mauritania to that in Mauritius?
Provide a succinct answer. 0.25. What is the ratio of the Emissions(kt) in 1963 in Mauritania to that in Mauritius?
Offer a terse response. 0.42. What is the ratio of the Emissions(kt) in 1960 in Mauritania to that in Mexico?
Make the answer very short. 0. What is the ratio of the Emissions(kt) in 1961 in Mauritania to that in Mexico?
Your answer should be compact. 0. What is the ratio of the Emissions(kt) of 1962 in Mauritania to that in Mexico?
Offer a terse response. 0. What is the ratio of the Emissions(kt) of 1963 in Mauritania to that in Mexico?
Provide a succinct answer. 0. What is the ratio of the Emissions(kt) of 1960 in Mauritius to that in Mexico?
Your answer should be compact. 0. What is the ratio of the Emissions(kt) of 1961 in Mauritius to that in Mexico?
Make the answer very short. 0. What is the ratio of the Emissions(kt) of 1962 in Mauritius to that in Mexico?
Give a very brief answer. 0. What is the ratio of the Emissions(kt) of 1963 in Mauritius to that in Mexico?
Make the answer very short. 0. What is the difference between the highest and the second highest Emissions(kt) of 1960?
Provide a succinct answer. 6.27e+04. What is the difference between the highest and the second highest Emissions(kt) in 1961?
Your answer should be compact. 6.49e+04. What is the difference between the highest and the second highest Emissions(kt) of 1962?
Your answer should be compact. 6.34e+04. What is the difference between the highest and the second highest Emissions(kt) in 1963?
Provide a short and direct response. 6.59e+04. What is the difference between the highest and the lowest Emissions(kt) in 1960?
Your response must be concise. 6.31e+04. What is the difference between the highest and the lowest Emissions(kt) of 1961?
Ensure brevity in your answer.  6.53e+04. What is the difference between the highest and the lowest Emissions(kt) in 1962?
Keep it short and to the point. 6.37e+04. What is the difference between the highest and the lowest Emissions(kt) in 1963?
Your response must be concise. 6.63e+04. 